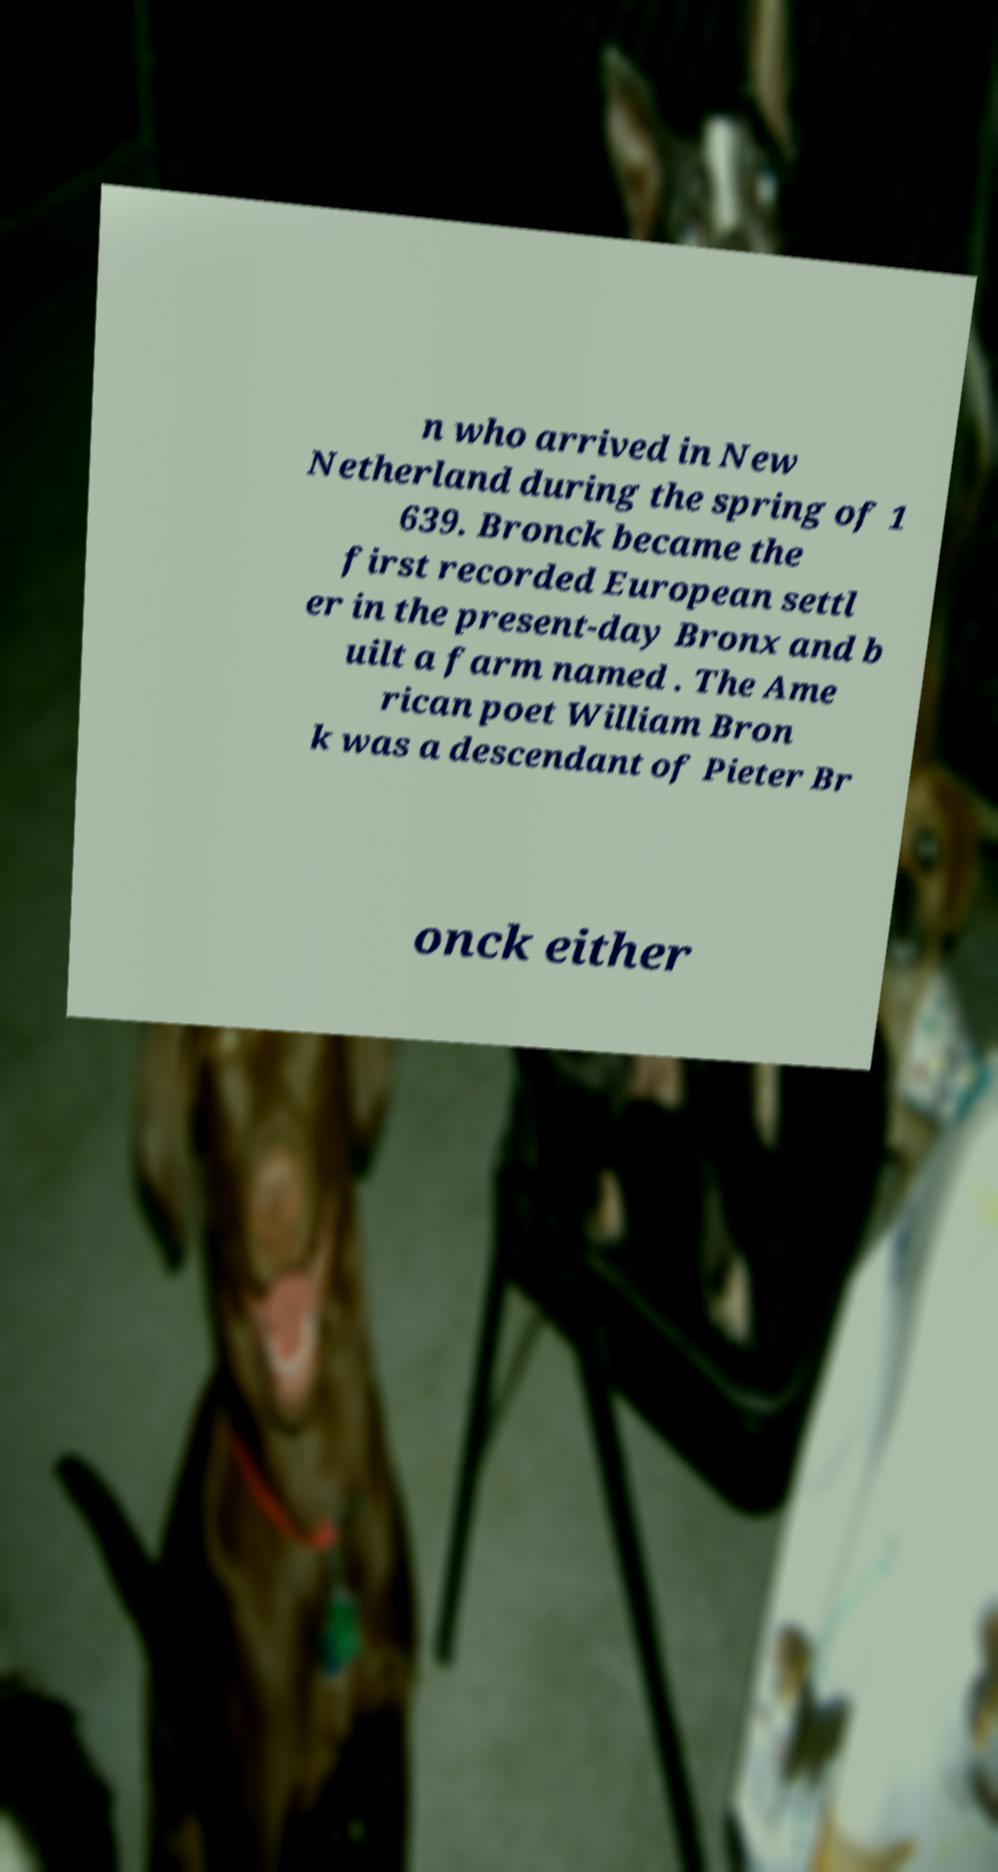I need the written content from this picture converted into text. Can you do that? n who arrived in New Netherland during the spring of 1 639. Bronck became the first recorded European settl er in the present-day Bronx and b uilt a farm named . The Ame rican poet William Bron k was a descendant of Pieter Br onck either 